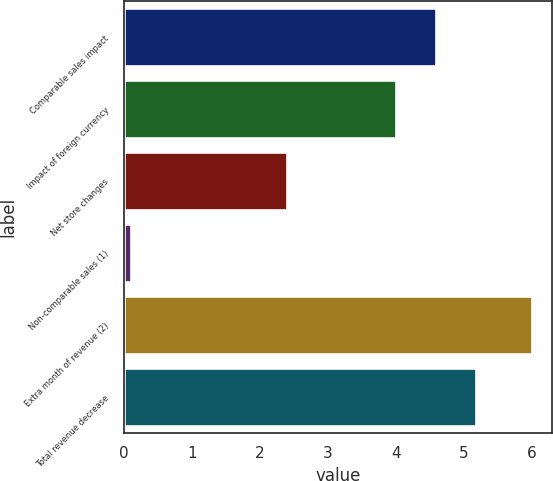Convert chart to OTSL. <chart><loc_0><loc_0><loc_500><loc_500><bar_chart><fcel>Comparable sales impact<fcel>Impact of foreign currency<fcel>Net store changes<fcel>Non-comparable sales (1)<fcel>Extra month of revenue (2)<fcel>Total revenue decrease<nl><fcel>4.59<fcel>4<fcel>2.4<fcel>0.1<fcel>6<fcel>5.18<nl></chart> 